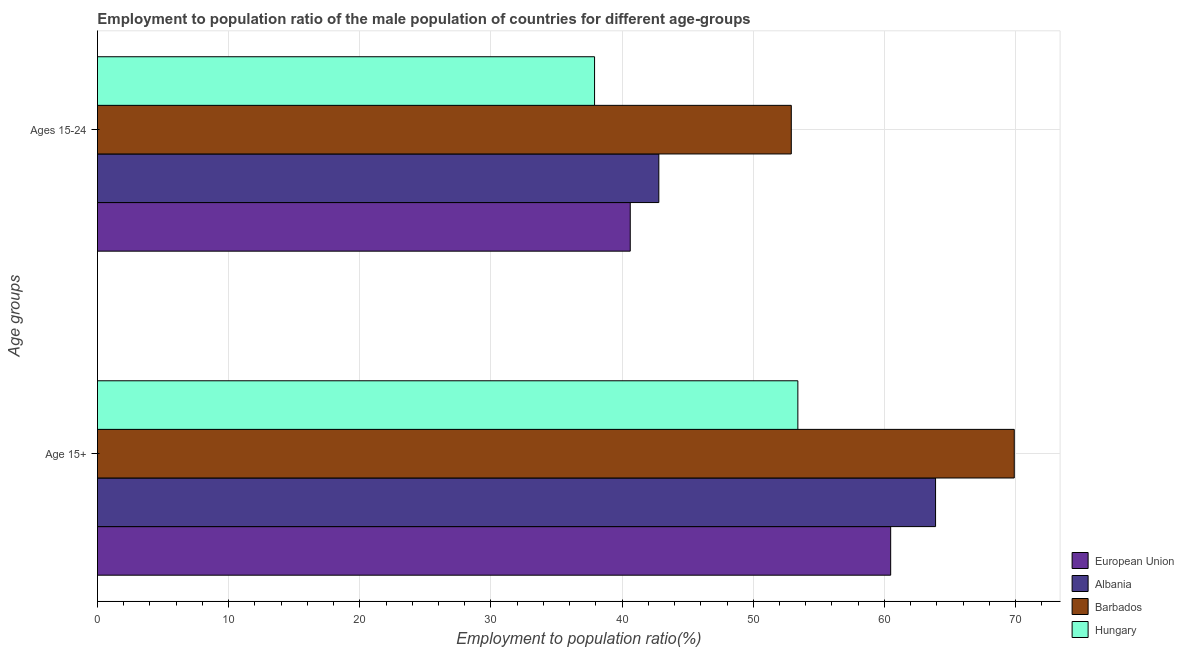How many groups of bars are there?
Offer a very short reply. 2. Are the number of bars on each tick of the Y-axis equal?
Offer a terse response. Yes. What is the label of the 1st group of bars from the top?
Make the answer very short. Ages 15-24. What is the employment to population ratio(age 15-24) in Barbados?
Your answer should be very brief. 52.9. Across all countries, what is the maximum employment to population ratio(age 15-24)?
Offer a very short reply. 52.9. Across all countries, what is the minimum employment to population ratio(age 15+)?
Ensure brevity in your answer.  53.4. In which country was the employment to population ratio(age 15+) maximum?
Your answer should be very brief. Barbados. In which country was the employment to population ratio(age 15+) minimum?
Make the answer very short. Hungary. What is the total employment to population ratio(age 15-24) in the graph?
Your answer should be very brief. 174.22. What is the difference between the employment to population ratio(age 15-24) in Barbados and that in Albania?
Your answer should be very brief. 10.1. What is the difference between the employment to population ratio(age 15+) in European Union and the employment to population ratio(age 15-24) in Hungary?
Offer a terse response. 22.58. What is the average employment to population ratio(age 15-24) per country?
Your answer should be very brief. 43.56. In how many countries, is the employment to population ratio(age 15+) greater than 18 %?
Your response must be concise. 4. What is the ratio of the employment to population ratio(age 15-24) in Albania to that in European Union?
Provide a succinct answer. 1.05. In how many countries, is the employment to population ratio(age 15+) greater than the average employment to population ratio(age 15+) taken over all countries?
Give a very brief answer. 2. What does the 3rd bar from the top in Ages 15-24 represents?
Your response must be concise. Albania. How many bars are there?
Your response must be concise. 8. What is the difference between two consecutive major ticks on the X-axis?
Your response must be concise. 10. Are the values on the major ticks of X-axis written in scientific E-notation?
Make the answer very short. No. Where does the legend appear in the graph?
Your answer should be very brief. Bottom right. How are the legend labels stacked?
Your answer should be compact. Vertical. What is the title of the graph?
Your response must be concise. Employment to population ratio of the male population of countries for different age-groups. Does "Guinea-Bissau" appear as one of the legend labels in the graph?
Provide a short and direct response. No. What is the label or title of the Y-axis?
Your response must be concise. Age groups. What is the Employment to population ratio(%) of European Union in Age 15+?
Keep it short and to the point. 60.48. What is the Employment to population ratio(%) in Albania in Age 15+?
Your answer should be compact. 63.9. What is the Employment to population ratio(%) in Barbados in Age 15+?
Keep it short and to the point. 69.9. What is the Employment to population ratio(%) of Hungary in Age 15+?
Keep it short and to the point. 53.4. What is the Employment to population ratio(%) in European Union in Ages 15-24?
Offer a very short reply. 40.62. What is the Employment to population ratio(%) in Albania in Ages 15-24?
Offer a very short reply. 42.8. What is the Employment to population ratio(%) of Barbados in Ages 15-24?
Make the answer very short. 52.9. What is the Employment to population ratio(%) in Hungary in Ages 15-24?
Your answer should be very brief. 37.9. Across all Age groups, what is the maximum Employment to population ratio(%) in European Union?
Your answer should be compact. 60.48. Across all Age groups, what is the maximum Employment to population ratio(%) in Albania?
Make the answer very short. 63.9. Across all Age groups, what is the maximum Employment to population ratio(%) of Barbados?
Provide a succinct answer. 69.9. Across all Age groups, what is the maximum Employment to population ratio(%) of Hungary?
Keep it short and to the point. 53.4. Across all Age groups, what is the minimum Employment to population ratio(%) in European Union?
Make the answer very short. 40.62. Across all Age groups, what is the minimum Employment to population ratio(%) of Albania?
Provide a short and direct response. 42.8. Across all Age groups, what is the minimum Employment to population ratio(%) of Barbados?
Offer a very short reply. 52.9. Across all Age groups, what is the minimum Employment to population ratio(%) of Hungary?
Offer a very short reply. 37.9. What is the total Employment to population ratio(%) in European Union in the graph?
Offer a terse response. 101.1. What is the total Employment to population ratio(%) in Albania in the graph?
Offer a very short reply. 106.7. What is the total Employment to population ratio(%) of Barbados in the graph?
Your answer should be compact. 122.8. What is the total Employment to population ratio(%) of Hungary in the graph?
Make the answer very short. 91.3. What is the difference between the Employment to population ratio(%) in European Union in Age 15+ and that in Ages 15-24?
Provide a short and direct response. 19.86. What is the difference between the Employment to population ratio(%) of Albania in Age 15+ and that in Ages 15-24?
Provide a succinct answer. 21.1. What is the difference between the Employment to population ratio(%) in European Union in Age 15+ and the Employment to population ratio(%) in Albania in Ages 15-24?
Your answer should be very brief. 17.68. What is the difference between the Employment to population ratio(%) in European Union in Age 15+ and the Employment to population ratio(%) in Barbados in Ages 15-24?
Your answer should be compact. 7.58. What is the difference between the Employment to population ratio(%) in European Union in Age 15+ and the Employment to population ratio(%) in Hungary in Ages 15-24?
Offer a very short reply. 22.58. What is the difference between the Employment to population ratio(%) in Albania in Age 15+ and the Employment to population ratio(%) in Hungary in Ages 15-24?
Your response must be concise. 26. What is the difference between the Employment to population ratio(%) of Barbados in Age 15+ and the Employment to population ratio(%) of Hungary in Ages 15-24?
Your answer should be very brief. 32. What is the average Employment to population ratio(%) of European Union per Age groups?
Offer a very short reply. 50.55. What is the average Employment to population ratio(%) of Albania per Age groups?
Offer a very short reply. 53.35. What is the average Employment to population ratio(%) in Barbados per Age groups?
Your answer should be very brief. 61.4. What is the average Employment to population ratio(%) of Hungary per Age groups?
Provide a short and direct response. 45.65. What is the difference between the Employment to population ratio(%) of European Union and Employment to population ratio(%) of Albania in Age 15+?
Your answer should be very brief. -3.42. What is the difference between the Employment to population ratio(%) in European Union and Employment to population ratio(%) in Barbados in Age 15+?
Ensure brevity in your answer.  -9.42. What is the difference between the Employment to population ratio(%) of European Union and Employment to population ratio(%) of Hungary in Age 15+?
Make the answer very short. 7.08. What is the difference between the Employment to population ratio(%) in Albania and Employment to population ratio(%) in Barbados in Age 15+?
Your answer should be very brief. -6. What is the difference between the Employment to population ratio(%) in Albania and Employment to population ratio(%) in Hungary in Age 15+?
Give a very brief answer. 10.5. What is the difference between the Employment to population ratio(%) in European Union and Employment to population ratio(%) in Albania in Ages 15-24?
Give a very brief answer. -2.18. What is the difference between the Employment to population ratio(%) in European Union and Employment to population ratio(%) in Barbados in Ages 15-24?
Give a very brief answer. -12.28. What is the difference between the Employment to population ratio(%) in European Union and Employment to population ratio(%) in Hungary in Ages 15-24?
Your answer should be very brief. 2.72. What is the ratio of the Employment to population ratio(%) in European Union in Age 15+ to that in Ages 15-24?
Offer a very short reply. 1.49. What is the ratio of the Employment to population ratio(%) in Albania in Age 15+ to that in Ages 15-24?
Provide a short and direct response. 1.49. What is the ratio of the Employment to population ratio(%) in Barbados in Age 15+ to that in Ages 15-24?
Your answer should be compact. 1.32. What is the ratio of the Employment to population ratio(%) in Hungary in Age 15+ to that in Ages 15-24?
Make the answer very short. 1.41. What is the difference between the highest and the second highest Employment to population ratio(%) in European Union?
Your response must be concise. 19.86. What is the difference between the highest and the second highest Employment to population ratio(%) in Albania?
Keep it short and to the point. 21.1. What is the difference between the highest and the second highest Employment to population ratio(%) in Barbados?
Your answer should be very brief. 17. What is the difference between the highest and the second highest Employment to population ratio(%) in Hungary?
Offer a very short reply. 15.5. What is the difference between the highest and the lowest Employment to population ratio(%) in European Union?
Make the answer very short. 19.86. What is the difference between the highest and the lowest Employment to population ratio(%) of Albania?
Offer a very short reply. 21.1. 